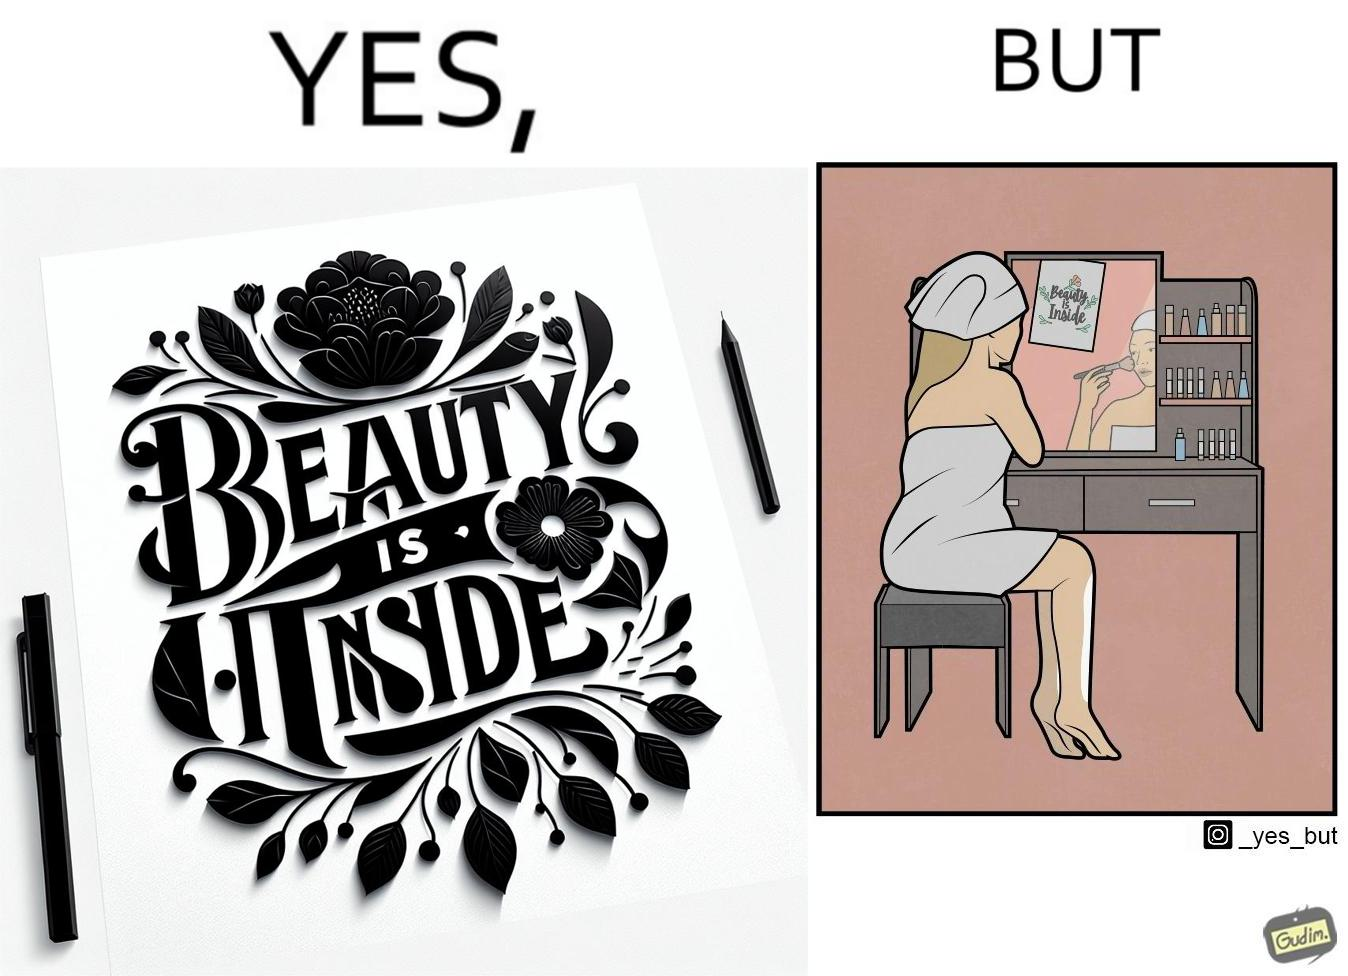What is shown in the left half versus the right half of this image? In the left part of the image: The image shows a text in beautiful font with flowers drawn around it. The text says "Beauty Is Inside". In the right part of the image: The image shows a woman applying makeup after shower by looking at herself in the dressing mirror. A piece of paper that says "Beauty is Inside" is clipped to the top of the mirror. 